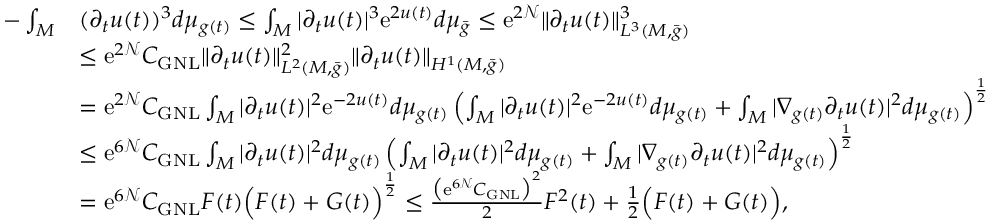<formula> <loc_0><loc_0><loc_500><loc_500>\begin{array} { r l } { - \int _ { M } } & { ( \partial _ { t } u ( t ) ) ^ { 3 } d \mu _ { g ( t ) } \leq \int _ { M } | \partial _ { t } u ( t ) | ^ { 3 } e ^ { 2 u ( t ) } d \mu _ { \bar { g } } \leq e ^ { 2 \mathcal { N } } \| \partial _ { t } u ( t ) \| _ { L ^ { 3 } ( M , \bar { g } ) } ^ { 3 } } \\ & { \leq e ^ { 2 \mathcal { N } } C _ { G N L } \| \partial _ { t } u ( t ) \| _ { L ^ { 2 } ( M , \bar { g } ) } ^ { 2 } \| \partial _ { t } u ( t ) \| _ { H ^ { 1 } ( M , \bar { g } ) } } \\ & { = e ^ { 2 \mathcal { N } } C _ { G N L } \int _ { M } | \partial _ { t } u ( t ) | ^ { 2 } e ^ { - 2 u ( t ) } d \mu _ { g ( t ) } \left ( \int _ { M } | \partial _ { t } u ( t ) | ^ { 2 } e ^ { - 2 u ( t ) } d \mu _ { g ( t ) } + \int _ { M } | \nabla _ { g ( t ) } \partial _ { t } u ( t ) | ^ { 2 } d \mu _ { g ( t ) } \right ) ^ { \frac { 1 } { 2 } } } \\ & { \leq e ^ { 6 \mathcal { N } } C _ { G N L } \int _ { M } | \partial _ { t } u ( t ) | ^ { 2 } d \mu _ { g ( t ) } \left ( \int _ { M } | \partial _ { t } u ( t ) | ^ { 2 } d \mu _ { g ( t ) } + \int _ { M } | \nabla _ { g ( t ) } \partial _ { t } u ( t ) | ^ { 2 } d \mu _ { g ( t ) } \right ) ^ { \frac { 1 } { 2 } } } \\ & { = e ^ { 6 \mathcal { N } } C _ { G N L } F ( t ) \left ( F ( t ) + G ( t ) \right ) ^ { \frac { 1 } { 2 } } \leq \frac { \left ( e ^ { 6 \mathcal { N } } C _ { G N L } \right ) ^ { 2 } } { 2 } F ^ { 2 } ( t ) + \frac { 1 } { 2 } \left ( F ( t ) + G ( t ) \right ) , } \end{array}</formula> 